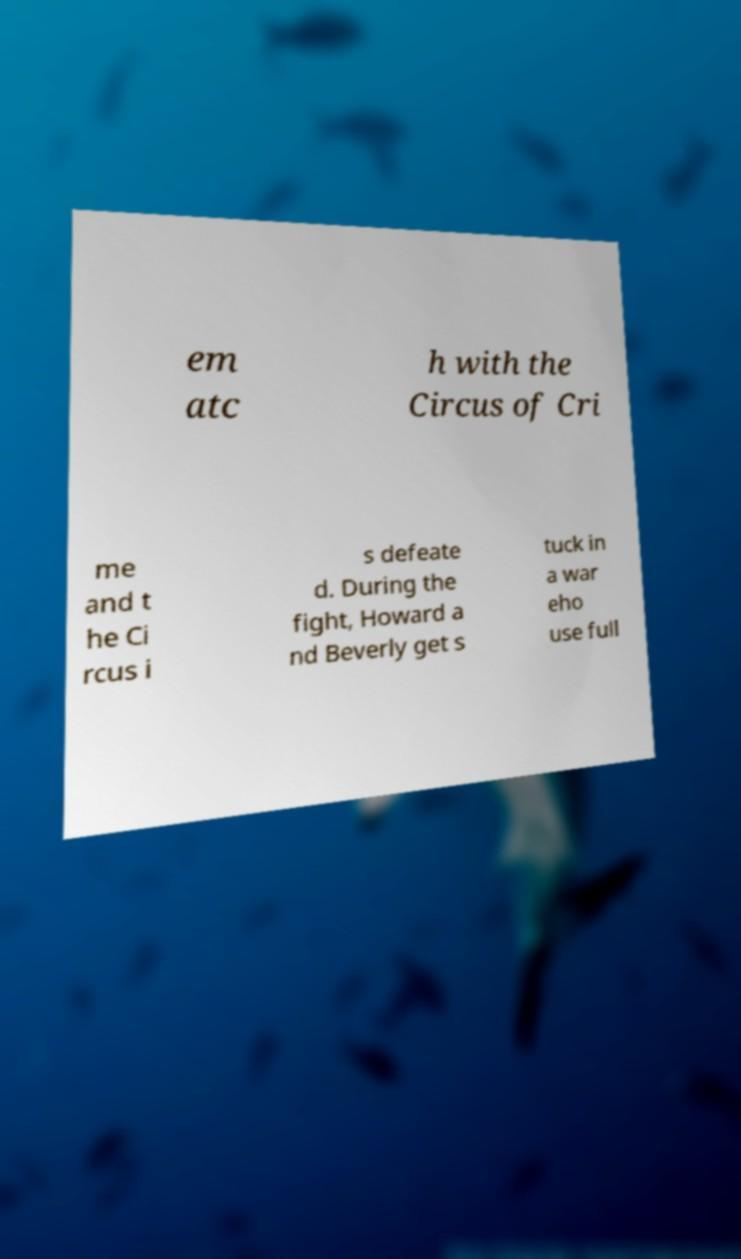What messages or text are displayed in this image? I need them in a readable, typed format. em atc h with the Circus of Cri me and t he Ci rcus i s defeate d. During the fight, Howard a nd Beverly get s tuck in a war eho use full 